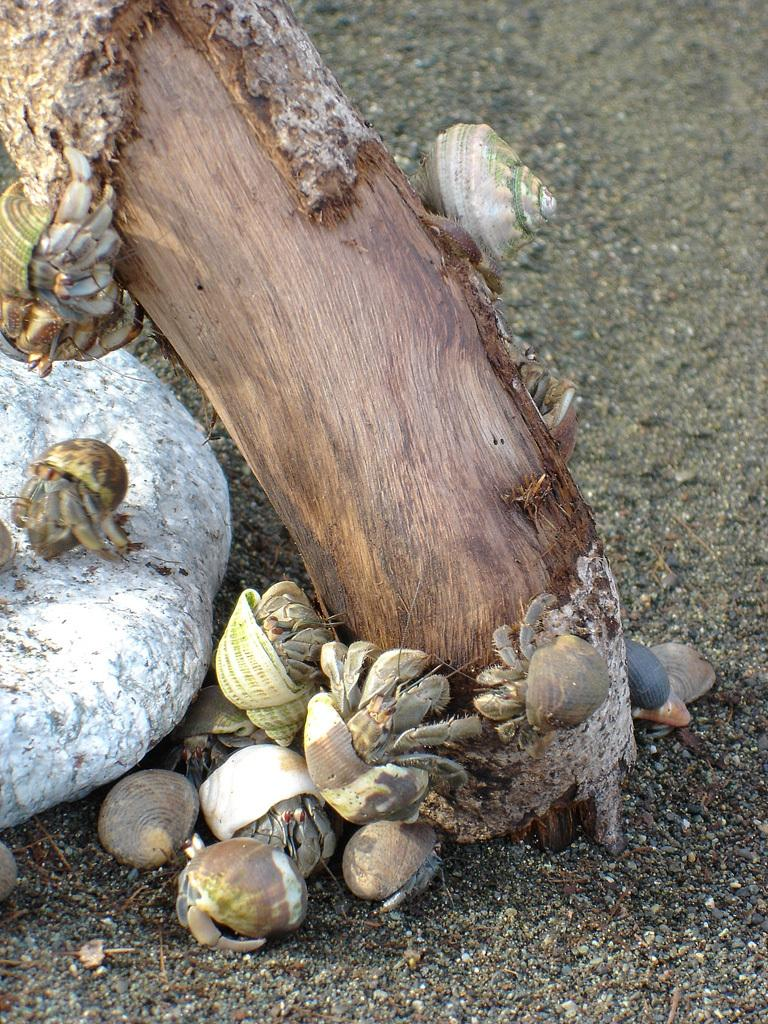What type of shells can be seen in the image? There are conchs in the image. What part of a tree is visible in the image? The trunk of a tree is present in the image. What type of rock is in the image? There is a stone in the image. What type of ground is visible in the image? Soil is visible in the image. What type of organization is depicted in the image? There is no organization present in the image; it features conchs, a tree trunk, a stone, and soil. How does the tent provide shelter in the image? There is no tent present in the image. 